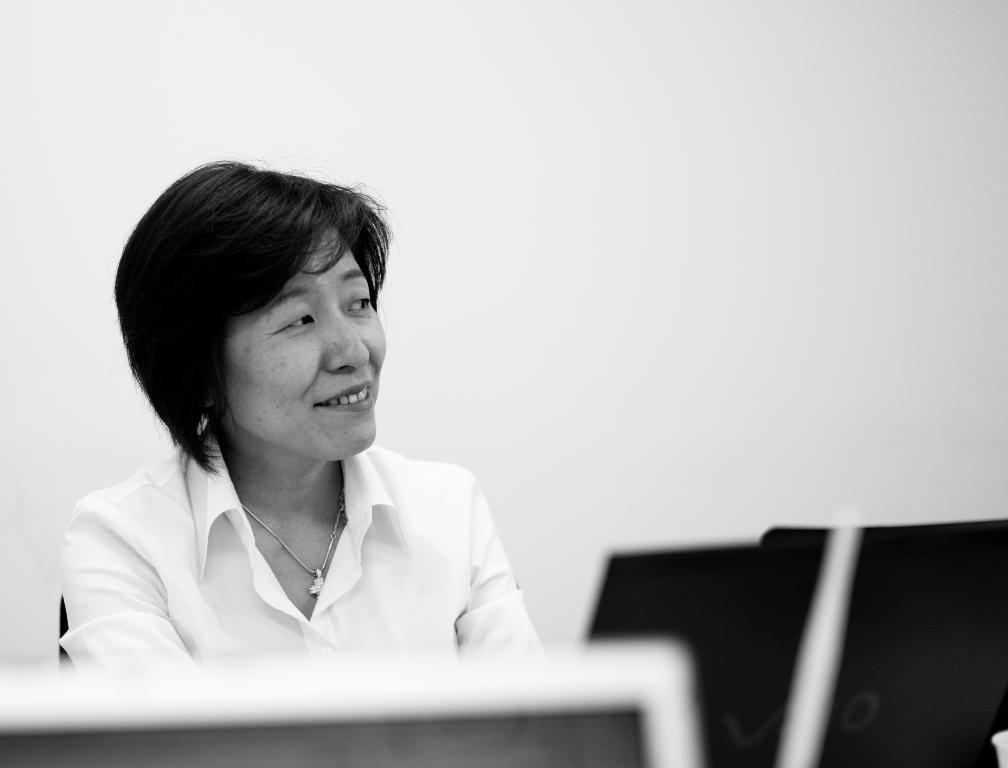Who is present in the image? There is a woman in the image. What is the woman wearing? The woman is wearing a white shirt. What can be seen in the background of the image? There is a wall in the background of the image. What color is the wall? The wall is white. What device is located at the bottom of the image? There is a monitor at the bottom of the image. What type of coat is the woman's uncle wearing in the image? There is no uncle or coat present in the image. What is the sum of the numbers 5 and 7 in the image? There are no numbers or addition in the image. 